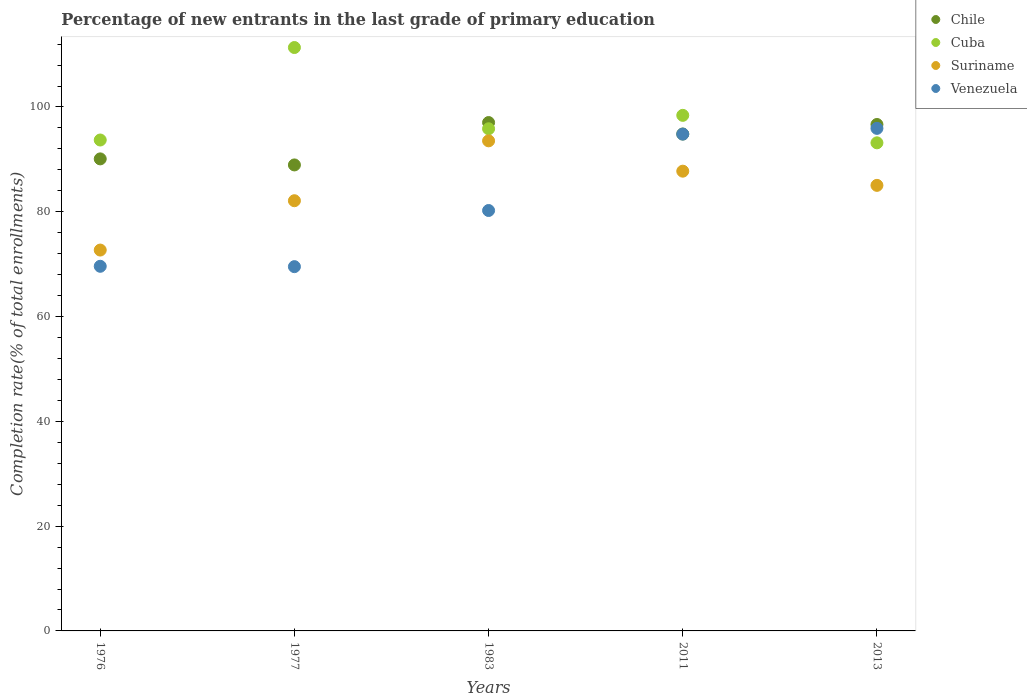How many different coloured dotlines are there?
Give a very brief answer. 4. Is the number of dotlines equal to the number of legend labels?
Make the answer very short. Yes. What is the percentage of new entrants in Venezuela in 1976?
Provide a succinct answer. 69.59. Across all years, what is the maximum percentage of new entrants in Suriname?
Your response must be concise. 93.53. Across all years, what is the minimum percentage of new entrants in Suriname?
Offer a very short reply. 72.69. In which year was the percentage of new entrants in Chile maximum?
Keep it short and to the point. 1983. In which year was the percentage of new entrants in Suriname minimum?
Ensure brevity in your answer.  1976. What is the total percentage of new entrants in Suriname in the graph?
Your answer should be very brief. 421.11. What is the difference between the percentage of new entrants in Venezuela in 1983 and that in 2011?
Give a very brief answer. -14.58. What is the difference between the percentage of new entrants in Chile in 1983 and the percentage of new entrants in Suriname in 2013?
Make the answer very short. 11.99. What is the average percentage of new entrants in Venezuela per year?
Offer a very short reply. 82.02. In the year 2011, what is the difference between the percentage of new entrants in Cuba and percentage of new entrants in Venezuela?
Make the answer very short. 3.58. What is the ratio of the percentage of new entrants in Suriname in 1976 to that in 1977?
Provide a succinct answer. 0.89. What is the difference between the highest and the second highest percentage of new entrants in Cuba?
Make the answer very short. 12.94. What is the difference between the highest and the lowest percentage of new entrants in Suriname?
Ensure brevity in your answer.  20.85. Is the sum of the percentage of new entrants in Suriname in 1983 and 2013 greater than the maximum percentage of new entrants in Cuba across all years?
Offer a terse response. Yes. Is the percentage of new entrants in Venezuela strictly greater than the percentage of new entrants in Suriname over the years?
Ensure brevity in your answer.  No. Is the percentage of new entrants in Venezuela strictly less than the percentage of new entrants in Chile over the years?
Offer a terse response. Yes. How many dotlines are there?
Provide a short and direct response. 4. How many years are there in the graph?
Provide a short and direct response. 5. What is the difference between two consecutive major ticks on the Y-axis?
Your answer should be very brief. 20. Does the graph contain any zero values?
Keep it short and to the point. No. How many legend labels are there?
Offer a terse response. 4. How are the legend labels stacked?
Keep it short and to the point. Vertical. What is the title of the graph?
Offer a terse response. Percentage of new entrants in the last grade of primary education. Does "St. Kitts and Nevis" appear as one of the legend labels in the graph?
Your response must be concise. No. What is the label or title of the X-axis?
Offer a very short reply. Years. What is the label or title of the Y-axis?
Your response must be concise. Completion rate(% of total enrollments). What is the Completion rate(% of total enrollments) of Chile in 1976?
Provide a short and direct response. 90.09. What is the Completion rate(% of total enrollments) in Cuba in 1976?
Provide a short and direct response. 93.69. What is the Completion rate(% of total enrollments) of Suriname in 1976?
Your response must be concise. 72.69. What is the Completion rate(% of total enrollments) in Venezuela in 1976?
Provide a short and direct response. 69.59. What is the Completion rate(% of total enrollments) in Chile in 1977?
Give a very brief answer. 88.94. What is the Completion rate(% of total enrollments) of Cuba in 1977?
Keep it short and to the point. 111.34. What is the Completion rate(% of total enrollments) of Suriname in 1977?
Keep it short and to the point. 82.11. What is the Completion rate(% of total enrollments) in Venezuela in 1977?
Give a very brief answer. 69.52. What is the Completion rate(% of total enrollments) of Chile in 1983?
Provide a short and direct response. 97.02. What is the Completion rate(% of total enrollments) of Cuba in 1983?
Offer a very short reply. 95.84. What is the Completion rate(% of total enrollments) in Suriname in 1983?
Your answer should be very brief. 93.53. What is the Completion rate(% of total enrollments) in Venezuela in 1983?
Ensure brevity in your answer.  80.24. What is the Completion rate(% of total enrollments) in Chile in 2011?
Your answer should be very brief. 94.84. What is the Completion rate(% of total enrollments) in Cuba in 2011?
Offer a terse response. 98.4. What is the Completion rate(% of total enrollments) of Suriname in 2011?
Provide a short and direct response. 87.75. What is the Completion rate(% of total enrollments) of Venezuela in 2011?
Provide a succinct answer. 94.82. What is the Completion rate(% of total enrollments) of Chile in 2013?
Your answer should be very brief. 96.66. What is the Completion rate(% of total enrollments) of Cuba in 2013?
Ensure brevity in your answer.  93.16. What is the Completion rate(% of total enrollments) of Suriname in 2013?
Offer a terse response. 85.04. What is the Completion rate(% of total enrollments) of Venezuela in 2013?
Your answer should be very brief. 95.91. Across all years, what is the maximum Completion rate(% of total enrollments) in Chile?
Give a very brief answer. 97.02. Across all years, what is the maximum Completion rate(% of total enrollments) of Cuba?
Offer a terse response. 111.34. Across all years, what is the maximum Completion rate(% of total enrollments) of Suriname?
Ensure brevity in your answer.  93.53. Across all years, what is the maximum Completion rate(% of total enrollments) of Venezuela?
Offer a terse response. 95.91. Across all years, what is the minimum Completion rate(% of total enrollments) in Chile?
Your answer should be very brief. 88.94. Across all years, what is the minimum Completion rate(% of total enrollments) in Cuba?
Your response must be concise. 93.16. Across all years, what is the minimum Completion rate(% of total enrollments) in Suriname?
Make the answer very short. 72.69. Across all years, what is the minimum Completion rate(% of total enrollments) in Venezuela?
Ensure brevity in your answer.  69.52. What is the total Completion rate(% of total enrollments) in Chile in the graph?
Keep it short and to the point. 467.54. What is the total Completion rate(% of total enrollments) of Cuba in the graph?
Offer a terse response. 492.43. What is the total Completion rate(% of total enrollments) of Suriname in the graph?
Make the answer very short. 421.11. What is the total Completion rate(% of total enrollments) of Venezuela in the graph?
Ensure brevity in your answer.  410.09. What is the difference between the Completion rate(% of total enrollments) of Chile in 1976 and that in 1977?
Provide a short and direct response. 1.15. What is the difference between the Completion rate(% of total enrollments) of Cuba in 1976 and that in 1977?
Keep it short and to the point. -17.65. What is the difference between the Completion rate(% of total enrollments) in Suriname in 1976 and that in 1977?
Provide a succinct answer. -9.42. What is the difference between the Completion rate(% of total enrollments) in Venezuela in 1976 and that in 1977?
Offer a very short reply. 0.07. What is the difference between the Completion rate(% of total enrollments) of Chile in 1976 and that in 1983?
Keep it short and to the point. -6.93. What is the difference between the Completion rate(% of total enrollments) of Cuba in 1976 and that in 1983?
Provide a short and direct response. -2.14. What is the difference between the Completion rate(% of total enrollments) in Suriname in 1976 and that in 1983?
Make the answer very short. -20.85. What is the difference between the Completion rate(% of total enrollments) in Venezuela in 1976 and that in 1983?
Make the answer very short. -10.65. What is the difference between the Completion rate(% of total enrollments) in Chile in 1976 and that in 2011?
Your response must be concise. -4.75. What is the difference between the Completion rate(% of total enrollments) in Cuba in 1976 and that in 2011?
Offer a terse response. -4.7. What is the difference between the Completion rate(% of total enrollments) in Suriname in 1976 and that in 2011?
Offer a very short reply. -15.06. What is the difference between the Completion rate(% of total enrollments) in Venezuela in 1976 and that in 2011?
Offer a terse response. -25.23. What is the difference between the Completion rate(% of total enrollments) in Chile in 1976 and that in 2013?
Your answer should be compact. -6.57. What is the difference between the Completion rate(% of total enrollments) of Cuba in 1976 and that in 2013?
Keep it short and to the point. 0.54. What is the difference between the Completion rate(% of total enrollments) in Suriname in 1976 and that in 2013?
Your response must be concise. -12.35. What is the difference between the Completion rate(% of total enrollments) of Venezuela in 1976 and that in 2013?
Keep it short and to the point. -26.32. What is the difference between the Completion rate(% of total enrollments) in Chile in 1977 and that in 1983?
Provide a succinct answer. -8.09. What is the difference between the Completion rate(% of total enrollments) in Cuba in 1977 and that in 1983?
Keep it short and to the point. 15.51. What is the difference between the Completion rate(% of total enrollments) in Suriname in 1977 and that in 1983?
Offer a terse response. -11.43. What is the difference between the Completion rate(% of total enrollments) of Venezuela in 1977 and that in 1983?
Keep it short and to the point. -10.72. What is the difference between the Completion rate(% of total enrollments) in Chile in 1977 and that in 2011?
Your response must be concise. -5.9. What is the difference between the Completion rate(% of total enrollments) in Cuba in 1977 and that in 2011?
Provide a short and direct response. 12.94. What is the difference between the Completion rate(% of total enrollments) in Suriname in 1977 and that in 2011?
Offer a terse response. -5.64. What is the difference between the Completion rate(% of total enrollments) of Venezuela in 1977 and that in 2011?
Your answer should be very brief. -25.3. What is the difference between the Completion rate(% of total enrollments) of Chile in 1977 and that in 2013?
Your answer should be compact. -7.72. What is the difference between the Completion rate(% of total enrollments) of Cuba in 1977 and that in 2013?
Ensure brevity in your answer.  18.19. What is the difference between the Completion rate(% of total enrollments) in Suriname in 1977 and that in 2013?
Provide a succinct answer. -2.93. What is the difference between the Completion rate(% of total enrollments) of Venezuela in 1977 and that in 2013?
Your answer should be compact. -26.39. What is the difference between the Completion rate(% of total enrollments) in Chile in 1983 and that in 2011?
Your answer should be compact. 2.19. What is the difference between the Completion rate(% of total enrollments) in Cuba in 1983 and that in 2011?
Your answer should be very brief. -2.56. What is the difference between the Completion rate(% of total enrollments) of Suriname in 1983 and that in 2011?
Offer a terse response. 5.79. What is the difference between the Completion rate(% of total enrollments) of Venezuela in 1983 and that in 2011?
Offer a very short reply. -14.58. What is the difference between the Completion rate(% of total enrollments) of Chile in 1983 and that in 2013?
Make the answer very short. 0.37. What is the difference between the Completion rate(% of total enrollments) in Cuba in 1983 and that in 2013?
Provide a short and direct response. 2.68. What is the difference between the Completion rate(% of total enrollments) of Suriname in 1983 and that in 2013?
Give a very brief answer. 8.5. What is the difference between the Completion rate(% of total enrollments) of Venezuela in 1983 and that in 2013?
Your answer should be compact. -15.68. What is the difference between the Completion rate(% of total enrollments) of Chile in 2011 and that in 2013?
Provide a succinct answer. -1.82. What is the difference between the Completion rate(% of total enrollments) in Cuba in 2011 and that in 2013?
Provide a short and direct response. 5.24. What is the difference between the Completion rate(% of total enrollments) in Suriname in 2011 and that in 2013?
Your answer should be compact. 2.71. What is the difference between the Completion rate(% of total enrollments) of Venezuela in 2011 and that in 2013?
Your response must be concise. -1.09. What is the difference between the Completion rate(% of total enrollments) in Chile in 1976 and the Completion rate(% of total enrollments) in Cuba in 1977?
Your answer should be compact. -21.25. What is the difference between the Completion rate(% of total enrollments) in Chile in 1976 and the Completion rate(% of total enrollments) in Suriname in 1977?
Your answer should be compact. 7.98. What is the difference between the Completion rate(% of total enrollments) in Chile in 1976 and the Completion rate(% of total enrollments) in Venezuela in 1977?
Keep it short and to the point. 20.57. What is the difference between the Completion rate(% of total enrollments) of Cuba in 1976 and the Completion rate(% of total enrollments) of Suriname in 1977?
Ensure brevity in your answer.  11.59. What is the difference between the Completion rate(% of total enrollments) of Cuba in 1976 and the Completion rate(% of total enrollments) of Venezuela in 1977?
Make the answer very short. 24.17. What is the difference between the Completion rate(% of total enrollments) in Suriname in 1976 and the Completion rate(% of total enrollments) in Venezuela in 1977?
Give a very brief answer. 3.17. What is the difference between the Completion rate(% of total enrollments) of Chile in 1976 and the Completion rate(% of total enrollments) of Cuba in 1983?
Give a very brief answer. -5.75. What is the difference between the Completion rate(% of total enrollments) in Chile in 1976 and the Completion rate(% of total enrollments) in Suriname in 1983?
Your response must be concise. -3.44. What is the difference between the Completion rate(% of total enrollments) in Chile in 1976 and the Completion rate(% of total enrollments) in Venezuela in 1983?
Make the answer very short. 9.85. What is the difference between the Completion rate(% of total enrollments) in Cuba in 1976 and the Completion rate(% of total enrollments) in Suriname in 1983?
Make the answer very short. 0.16. What is the difference between the Completion rate(% of total enrollments) of Cuba in 1976 and the Completion rate(% of total enrollments) of Venezuela in 1983?
Make the answer very short. 13.45. What is the difference between the Completion rate(% of total enrollments) in Suriname in 1976 and the Completion rate(% of total enrollments) in Venezuela in 1983?
Provide a succinct answer. -7.55. What is the difference between the Completion rate(% of total enrollments) in Chile in 1976 and the Completion rate(% of total enrollments) in Cuba in 2011?
Provide a short and direct response. -8.31. What is the difference between the Completion rate(% of total enrollments) of Chile in 1976 and the Completion rate(% of total enrollments) of Suriname in 2011?
Your response must be concise. 2.34. What is the difference between the Completion rate(% of total enrollments) of Chile in 1976 and the Completion rate(% of total enrollments) of Venezuela in 2011?
Give a very brief answer. -4.73. What is the difference between the Completion rate(% of total enrollments) in Cuba in 1976 and the Completion rate(% of total enrollments) in Suriname in 2011?
Your answer should be very brief. 5.95. What is the difference between the Completion rate(% of total enrollments) in Cuba in 1976 and the Completion rate(% of total enrollments) in Venezuela in 2011?
Ensure brevity in your answer.  -1.13. What is the difference between the Completion rate(% of total enrollments) in Suriname in 1976 and the Completion rate(% of total enrollments) in Venezuela in 2011?
Your answer should be compact. -22.13. What is the difference between the Completion rate(% of total enrollments) of Chile in 1976 and the Completion rate(% of total enrollments) of Cuba in 2013?
Give a very brief answer. -3.06. What is the difference between the Completion rate(% of total enrollments) in Chile in 1976 and the Completion rate(% of total enrollments) in Suriname in 2013?
Provide a succinct answer. 5.05. What is the difference between the Completion rate(% of total enrollments) of Chile in 1976 and the Completion rate(% of total enrollments) of Venezuela in 2013?
Your answer should be compact. -5.82. What is the difference between the Completion rate(% of total enrollments) of Cuba in 1976 and the Completion rate(% of total enrollments) of Suriname in 2013?
Make the answer very short. 8.66. What is the difference between the Completion rate(% of total enrollments) of Cuba in 1976 and the Completion rate(% of total enrollments) of Venezuela in 2013?
Provide a succinct answer. -2.22. What is the difference between the Completion rate(% of total enrollments) in Suriname in 1976 and the Completion rate(% of total enrollments) in Venezuela in 2013?
Your answer should be compact. -23.23. What is the difference between the Completion rate(% of total enrollments) in Chile in 1977 and the Completion rate(% of total enrollments) in Cuba in 1983?
Provide a succinct answer. -6.9. What is the difference between the Completion rate(% of total enrollments) of Chile in 1977 and the Completion rate(% of total enrollments) of Suriname in 1983?
Provide a short and direct response. -4.6. What is the difference between the Completion rate(% of total enrollments) of Chile in 1977 and the Completion rate(% of total enrollments) of Venezuela in 1983?
Your answer should be very brief. 8.7. What is the difference between the Completion rate(% of total enrollments) of Cuba in 1977 and the Completion rate(% of total enrollments) of Suriname in 1983?
Give a very brief answer. 17.81. What is the difference between the Completion rate(% of total enrollments) of Cuba in 1977 and the Completion rate(% of total enrollments) of Venezuela in 1983?
Ensure brevity in your answer.  31.1. What is the difference between the Completion rate(% of total enrollments) in Suriname in 1977 and the Completion rate(% of total enrollments) in Venezuela in 1983?
Provide a succinct answer. 1.87. What is the difference between the Completion rate(% of total enrollments) in Chile in 1977 and the Completion rate(% of total enrollments) in Cuba in 2011?
Provide a succinct answer. -9.46. What is the difference between the Completion rate(% of total enrollments) in Chile in 1977 and the Completion rate(% of total enrollments) in Suriname in 2011?
Give a very brief answer. 1.19. What is the difference between the Completion rate(% of total enrollments) in Chile in 1977 and the Completion rate(% of total enrollments) in Venezuela in 2011?
Make the answer very short. -5.88. What is the difference between the Completion rate(% of total enrollments) in Cuba in 1977 and the Completion rate(% of total enrollments) in Suriname in 2011?
Offer a terse response. 23.6. What is the difference between the Completion rate(% of total enrollments) in Cuba in 1977 and the Completion rate(% of total enrollments) in Venezuela in 2011?
Make the answer very short. 16.52. What is the difference between the Completion rate(% of total enrollments) in Suriname in 1977 and the Completion rate(% of total enrollments) in Venezuela in 2011?
Your answer should be compact. -12.71. What is the difference between the Completion rate(% of total enrollments) of Chile in 1977 and the Completion rate(% of total enrollments) of Cuba in 2013?
Ensure brevity in your answer.  -4.22. What is the difference between the Completion rate(% of total enrollments) of Chile in 1977 and the Completion rate(% of total enrollments) of Suriname in 2013?
Your response must be concise. 3.9. What is the difference between the Completion rate(% of total enrollments) of Chile in 1977 and the Completion rate(% of total enrollments) of Venezuela in 2013?
Keep it short and to the point. -6.98. What is the difference between the Completion rate(% of total enrollments) of Cuba in 1977 and the Completion rate(% of total enrollments) of Suriname in 2013?
Keep it short and to the point. 26.31. What is the difference between the Completion rate(% of total enrollments) of Cuba in 1977 and the Completion rate(% of total enrollments) of Venezuela in 2013?
Provide a short and direct response. 15.43. What is the difference between the Completion rate(% of total enrollments) of Suriname in 1977 and the Completion rate(% of total enrollments) of Venezuela in 2013?
Your answer should be compact. -13.81. What is the difference between the Completion rate(% of total enrollments) of Chile in 1983 and the Completion rate(% of total enrollments) of Cuba in 2011?
Give a very brief answer. -1.37. What is the difference between the Completion rate(% of total enrollments) of Chile in 1983 and the Completion rate(% of total enrollments) of Suriname in 2011?
Keep it short and to the point. 9.28. What is the difference between the Completion rate(% of total enrollments) of Chile in 1983 and the Completion rate(% of total enrollments) of Venezuela in 2011?
Give a very brief answer. 2.2. What is the difference between the Completion rate(% of total enrollments) of Cuba in 1983 and the Completion rate(% of total enrollments) of Suriname in 2011?
Your response must be concise. 8.09. What is the difference between the Completion rate(% of total enrollments) in Cuba in 1983 and the Completion rate(% of total enrollments) in Venezuela in 2011?
Keep it short and to the point. 1.02. What is the difference between the Completion rate(% of total enrollments) of Suriname in 1983 and the Completion rate(% of total enrollments) of Venezuela in 2011?
Provide a short and direct response. -1.29. What is the difference between the Completion rate(% of total enrollments) in Chile in 1983 and the Completion rate(% of total enrollments) in Cuba in 2013?
Give a very brief answer. 3.87. What is the difference between the Completion rate(% of total enrollments) of Chile in 1983 and the Completion rate(% of total enrollments) of Suriname in 2013?
Provide a succinct answer. 11.99. What is the difference between the Completion rate(% of total enrollments) of Chile in 1983 and the Completion rate(% of total enrollments) of Venezuela in 2013?
Offer a very short reply. 1.11. What is the difference between the Completion rate(% of total enrollments) of Cuba in 1983 and the Completion rate(% of total enrollments) of Suriname in 2013?
Provide a succinct answer. 10.8. What is the difference between the Completion rate(% of total enrollments) of Cuba in 1983 and the Completion rate(% of total enrollments) of Venezuela in 2013?
Offer a very short reply. -0.08. What is the difference between the Completion rate(% of total enrollments) in Suriname in 1983 and the Completion rate(% of total enrollments) in Venezuela in 2013?
Make the answer very short. -2.38. What is the difference between the Completion rate(% of total enrollments) of Chile in 2011 and the Completion rate(% of total enrollments) of Cuba in 2013?
Offer a terse response. 1.68. What is the difference between the Completion rate(% of total enrollments) of Chile in 2011 and the Completion rate(% of total enrollments) of Suriname in 2013?
Your answer should be compact. 9.8. What is the difference between the Completion rate(% of total enrollments) in Chile in 2011 and the Completion rate(% of total enrollments) in Venezuela in 2013?
Your answer should be very brief. -1.08. What is the difference between the Completion rate(% of total enrollments) in Cuba in 2011 and the Completion rate(% of total enrollments) in Suriname in 2013?
Give a very brief answer. 13.36. What is the difference between the Completion rate(% of total enrollments) in Cuba in 2011 and the Completion rate(% of total enrollments) in Venezuela in 2013?
Make the answer very short. 2.48. What is the difference between the Completion rate(% of total enrollments) in Suriname in 2011 and the Completion rate(% of total enrollments) in Venezuela in 2013?
Make the answer very short. -8.17. What is the average Completion rate(% of total enrollments) of Chile per year?
Provide a succinct answer. 93.51. What is the average Completion rate(% of total enrollments) in Cuba per year?
Your response must be concise. 98.49. What is the average Completion rate(% of total enrollments) in Suriname per year?
Ensure brevity in your answer.  84.22. What is the average Completion rate(% of total enrollments) of Venezuela per year?
Your answer should be compact. 82.02. In the year 1976, what is the difference between the Completion rate(% of total enrollments) of Chile and Completion rate(% of total enrollments) of Cuba?
Ensure brevity in your answer.  -3.6. In the year 1976, what is the difference between the Completion rate(% of total enrollments) in Chile and Completion rate(% of total enrollments) in Suriname?
Provide a short and direct response. 17.4. In the year 1976, what is the difference between the Completion rate(% of total enrollments) of Chile and Completion rate(% of total enrollments) of Venezuela?
Your response must be concise. 20.5. In the year 1976, what is the difference between the Completion rate(% of total enrollments) of Cuba and Completion rate(% of total enrollments) of Suriname?
Offer a very short reply. 21.01. In the year 1976, what is the difference between the Completion rate(% of total enrollments) of Cuba and Completion rate(% of total enrollments) of Venezuela?
Provide a succinct answer. 24.1. In the year 1976, what is the difference between the Completion rate(% of total enrollments) of Suriname and Completion rate(% of total enrollments) of Venezuela?
Provide a succinct answer. 3.1. In the year 1977, what is the difference between the Completion rate(% of total enrollments) of Chile and Completion rate(% of total enrollments) of Cuba?
Your response must be concise. -22.41. In the year 1977, what is the difference between the Completion rate(% of total enrollments) in Chile and Completion rate(% of total enrollments) in Suriname?
Your answer should be compact. 6.83. In the year 1977, what is the difference between the Completion rate(% of total enrollments) of Chile and Completion rate(% of total enrollments) of Venezuela?
Your response must be concise. 19.41. In the year 1977, what is the difference between the Completion rate(% of total enrollments) in Cuba and Completion rate(% of total enrollments) in Suriname?
Your answer should be very brief. 29.24. In the year 1977, what is the difference between the Completion rate(% of total enrollments) in Cuba and Completion rate(% of total enrollments) in Venezuela?
Your answer should be compact. 41.82. In the year 1977, what is the difference between the Completion rate(% of total enrollments) of Suriname and Completion rate(% of total enrollments) of Venezuela?
Give a very brief answer. 12.58. In the year 1983, what is the difference between the Completion rate(% of total enrollments) of Chile and Completion rate(% of total enrollments) of Cuba?
Your answer should be very brief. 1.19. In the year 1983, what is the difference between the Completion rate(% of total enrollments) in Chile and Completion rate(% of total enrollments) in Suriname?
Keep it short and to the point. 3.49. In the year 1983, what is the difference between the Completion rate(% of total enrollments) in Chile and Completion rate(% of total enrollments) in Venezuela?
Your response must be concise. 16.79. In the year 1983, what is the difference between the Completion rate(% of total enrollments) of Cuba and Completion rate(% of total enrollments) of Suriname?
Provide a succinct answer. 2.3. In the year 1983, what is the difference between the Completion rate(% of total enrollments) in Cuba and Completion rate(% of total enrollments) in Venezuela?
Give a very brief answer. 15.6. In the year 1983, what is the difference between the Completion rate(% of total enrollments) in Suriname and Completion rate(% of total enrollments) in Venezuela?
Give a very brief answer. 13.29. In the year 2011, what is the difference between the Completion rate(% of total enrollments) in Chile and Completion rate(% of total enrollments) in Cuba?
Provide a short and direct response. -3.56. In the year 2011, what is the difference between the Completion rate(% of total enrollments) of Chile and Completion rate(% of total enrollments) of Suriname?
Provide a succinct answer. 7.09. In the year 2011, what is the difference between the Completion rate(% of total enrollments) of Chile and Completion rate(% of total enrollments) of Venezuela?
Offer a very short reply. 0.02. In the year 2011, what is the difference between the Completion rate(% of total enrollments) in Cuba and Completion rate(% of total enrollments) in Suriname?
Make the answer very short. 10.65. In the year 2011, what is the difference between the Completion rate(% of total enrollments) of Cuba and Completion rate(% of total enrollments) of Venezuela?
Offer a terse response. 3.58. In the year 2011, what is the difference between the Completion rate(% of total enrollments) in Suriname and Completion rate(% of total enrollments) in Venezuela?
Ensure brevity in your answer.  -7.08. In the year 2013, what is the difference between the Completion rate(% of total enrollments) of Chile and Completion rate(% of total enrollments) of Cuba?
Ensure brevity in your answer.  3.5. In the year 2013, what is the difference between the Completion rate(% of total enrollments) in Chile and Completion rate(% of total enrollments) in Suriname?
Provide a succinct answer. 11.62. In the year 2013, what is the difference between the Completion rate(% of total enrollments) of Chile and Completion rate(% of total enrollments) of Venezuela?
Your response must be concise. 0.74. In the year 2013, what is the difference between the Completion rate(% of total enrollments) in Cuba and Completion rate(% of total enrollments) in Suriname?
Provide a succinct answer. 8.12. In the year 2013, what is the difference between the Completion rate(% of total enrollments) in Cuba and Completion rate(% of total enrollments) in Venezuela?
Ensure brevity in your answer.  -2.76. In the year 2013, what is the difference between the Completion rate(% of total enrollments) in Suriname and Completion rate(% of total enrollments) in Venezuela?
Your answer should be very brief. -10.88. What is the ratio of the Completion rate(% of total enrollments) of Cuba in 1976 to that in 1977?
Provide a short and direct response. 0.84. What is the ratio of the Completion rate(% of total enrollments) in Suriname in 1976 to that in 1977?
Your answer should be compact. 0.89. What is the ratio of the Completion rate(% of total enrollments) in Chile in 1976 to that in 1983?
Ensure brevity in your answer.  0.93. What is the ratio of the Completion rate(% of total enrollments) of Cuba in 1976 to that in 1983?
Keep it short and to the point. 0.98. What is the ratio of the Completion rate(% of total enrollments) of Suriname in 1976 to that in 1983?
Provide a succinct answer. 0.78. What is the ratio of the Completion rate(% of total enrollments) of Venezuela in 1976 to that in 1983?
Your answer should be compact. 0.87. What is the ratio of the Completion rate(% of total enrollments) in Cuba in 1976 to that in 2011?
Your answer should be compact. 0.95. What is the ratio of the Completion rate(% of total enrollments) of Suriname in 1976 to that in 2011?
Your response must be concise. 0.83. What is the ratio of the Completion rate(% of total enrollments) of Venezuela in 1976 to that in 2011?
Your response must be concise. 0.73. What is the ratio of the Completion rate(% of total enrollments) in Chile in 1976 to that in 2013?
Keep it short and to the point. 0.93. What is the ratio of the Completion rate(% of total enrollments) in Cuba in 1976 to that in 2013?
Provide a succinct answer. 1.01. What is the ratio of the Completion rate(% of total enrollments) of Suriname in 1976 to that in 2013?
Your answer should be very brief. 0.85. What is the ratio of the Completion rate(% of total enrollments) in Venezuela in 1976 to that in 2013?
Your answer should be very brief. 0.73. What is the ratio of the Completion rate(% of total enrollments) in Chile in 1977 to that in 1983?
Offer a very short reply. 0.92. What is the ratio of the Completion rate(% of total enrollments) in Cuba in 1977 to that in 1983?
Provide a succinct answer. 1.16. What is the ratio of the Completion rate(% of total enrollments) in Suriname in 1977 to that in 1983?
Your answer should be compact. 0.88. What is the ratio of the Completion rate(% of total enrollments) in Venezuela in 1977 to that in 1983?
Provide a short and direct response. 0.87. What is the ratio of the Completion rate(% of total enrollments) of Chile in 1977 to that in 2011?
Your answer should be very brief. 0.94. What is the ratio of the Completion rate(% of total enrollments) in Cuba in 1977 to that in 2011?
Give a very brief answer. 1.13. What is the ratio of the Completion rate(% of total enrollments) in Suriname in 1977 to that in 2011?
Offer a terse response. 0.94. What is the ratio of the Completion rate(% of total enrollments) in Venezuela in 1977 to that in 2011?
Keep it short and to the point. 0.73. What is the ratio of the Completion rate(% of total enrollments) in Chile in 1977 to that in 2013?
Provide a succinct answer. 0.92. What is the ratio of the Completion rate(% of total enrollments) of Cuba in 1977 to that in 2013?
Give a very brief answer. 1.2. What is the ratio of the Completion rate(% of total enrollments) in Suriname in 1977 to that in 2013?
Offer a terse response. 0.97. What is the ratio of the Completion rate(% of total enrollments) in Venezuela in 1977 to that in 2013?
Your response must be concise. 0.72. What is the ratio of the Completion rate(% of total enrollments) in Chile in 1983 to that in 2011?
Your answer should be compact. 1.02. What is the ratio of the Completion rate(% of total enrollments) in Suriname in 1983 to that in 2011?
Offer a very short reply. 1.07. What is the ratio of the Completion rate(% of total enrollments) of Venezuela in 1983 to that in 2011?
Provide a short and direct response. 0.85. What is the ratio of the Completion rate(% of total enrollments) in Chile in 1983 to that in 2013?
Provide a succinct answer. 1. What is the ratio of the Completion rate(% of total enrollments) of Cuba in 1983 to that in 2013?
Give a very brief answer. 1.03. What is the ratio of the Completion rate(% of total enrollments) of Suriname in 1983 to that in 2013?
Ensure brevity in your answer.  1.1. What is the ratio of the Completion rate(% of total enrollments) of Venezuela in 1983 to that in 2013?
Offer a terse response. 0.84. What is the ratio of the Completion rate(% of total enrollments) of Chile in 2011 to that in 2013?
Your answer should be compact. 0.98. What is the ratio of the Completion rate(% of total enrollments) of Cuba in 2011 to that in 2013?
Provide a short and direct response. 1.06. What is the ratio of the Completion rate(% of total enrollments) of Suriname in 2011 to that in 2013?
Your answer should be compact. 1.03. What is the ratio of the Completion rate(% of total enrollments) in Venezuela in 2011 to that in 2013?
Ensure brevity in your answer.  0.99. What is the difference between the highest and the second highest Completion rate(% of total enrollments) in Chile?
Offer a terse response. 0.37. What is the difference between the highest and the second highest Completion rate(% of total enrollments) in Cuba?
Offer a very short reply. 12.94. What is the difference between the highest and the second highest Completion rate(% of total enrollments) of Suriname?
Provide a short and direct response. 5.79. What is the difference between the highest and the second highest Completion rate(% of total enrollments) of Venezuela?
Keep it short and to the point. 1.09. What is the difference between the highest and the lowest Completion rate(% of total enrollments) of Chile?
Provide a short and direct response. 8.09. What is the difference between the highest and the lowest Completion rate(% of total enrollments) of Cuba?
Give a very brief answer. 18.19. What is the difference between the highest and the lowest Completion rate(% of total enrollments) of Suriname?
Make the answer very short. 20.85. What is the difference between the highest and the lowest Completion rate(% of total enrollments) of Venezuela?
Your answer should be compact. 26.39. 